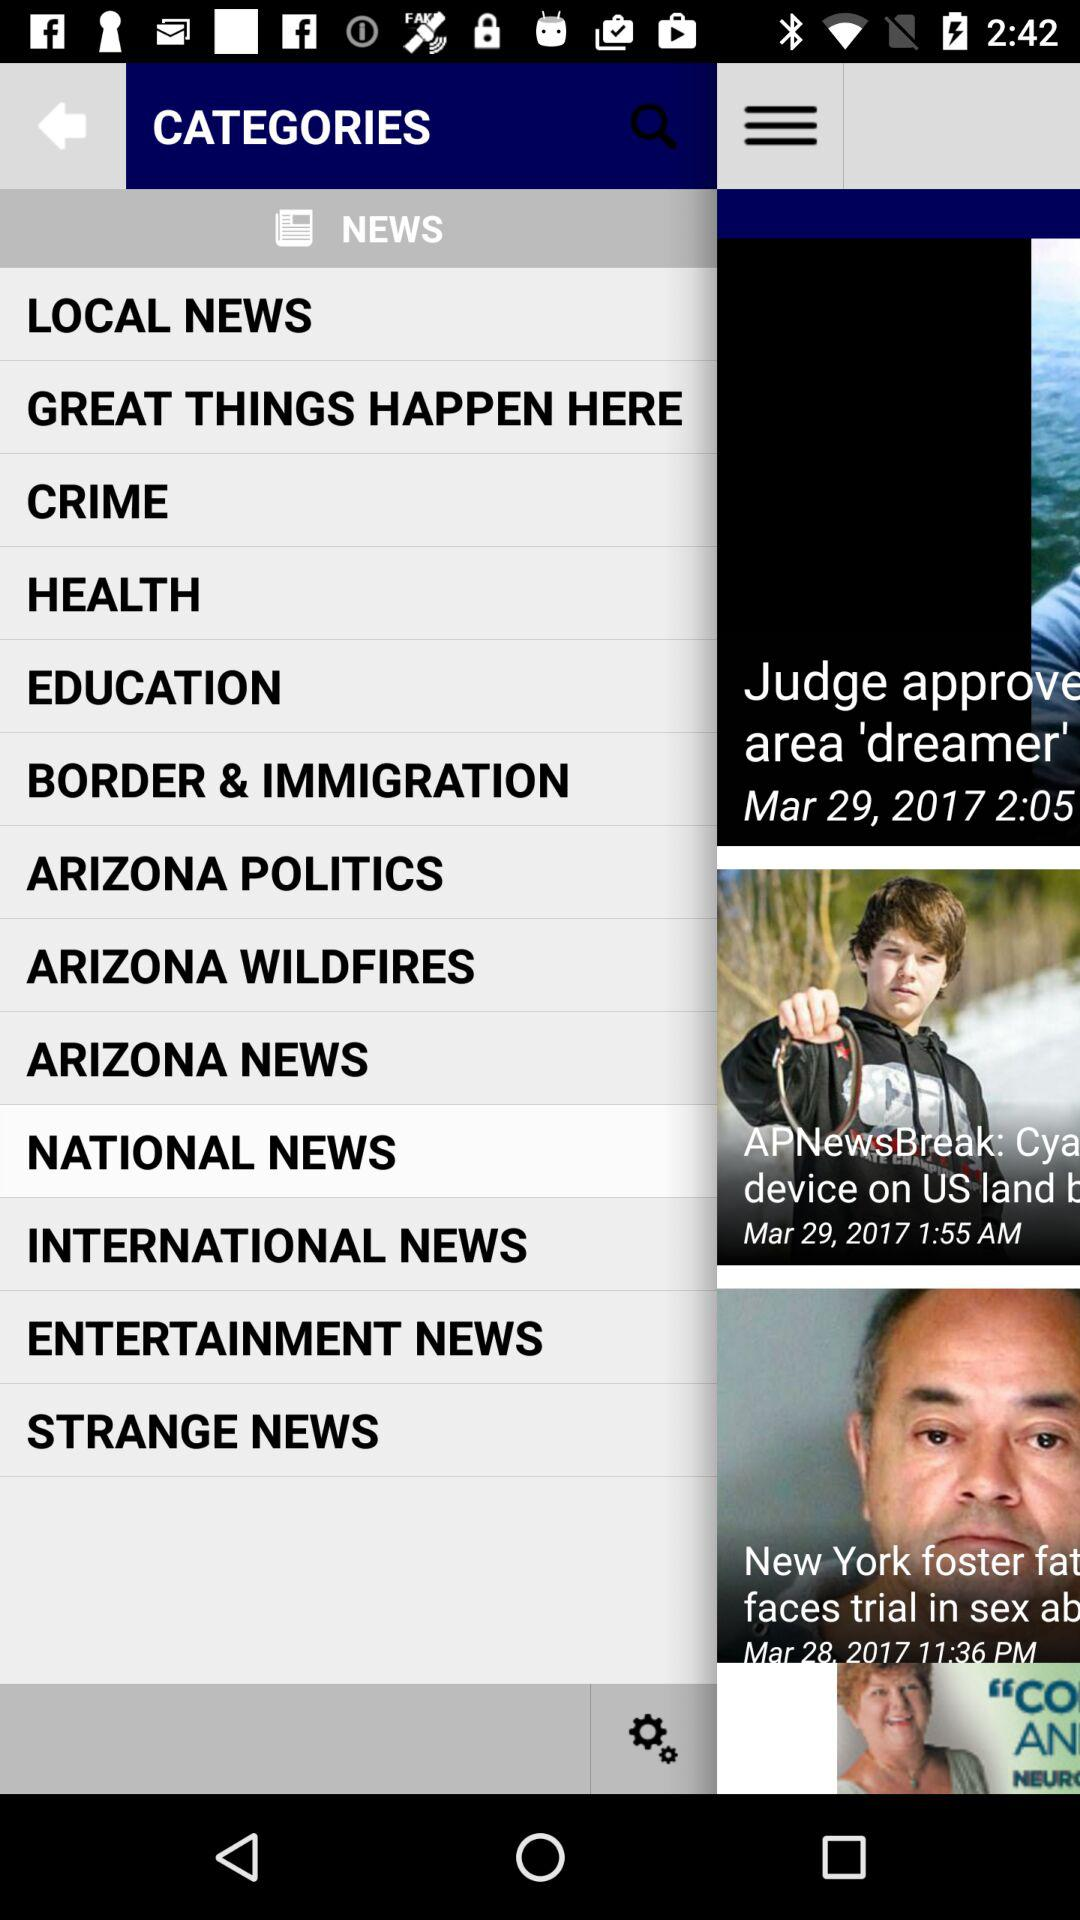What are the items available in the "NEWS" category? The items available in the "NEWS" category are "LOCAL NEWS", "GREAT THINGS HAPPEN HERE", "CRIME", "HEALTH", "EDUCATION", "BORDER & IMMIGRATION", "ARIZONA POLITICS", "ARIZONA WILDFIRES", "ARIZONA NEWS", "NATIONAL NEWS", "INTERNATIONAL NEWS", "ENTERTAINMENT NEWS" and "STRANGE NEWS". 